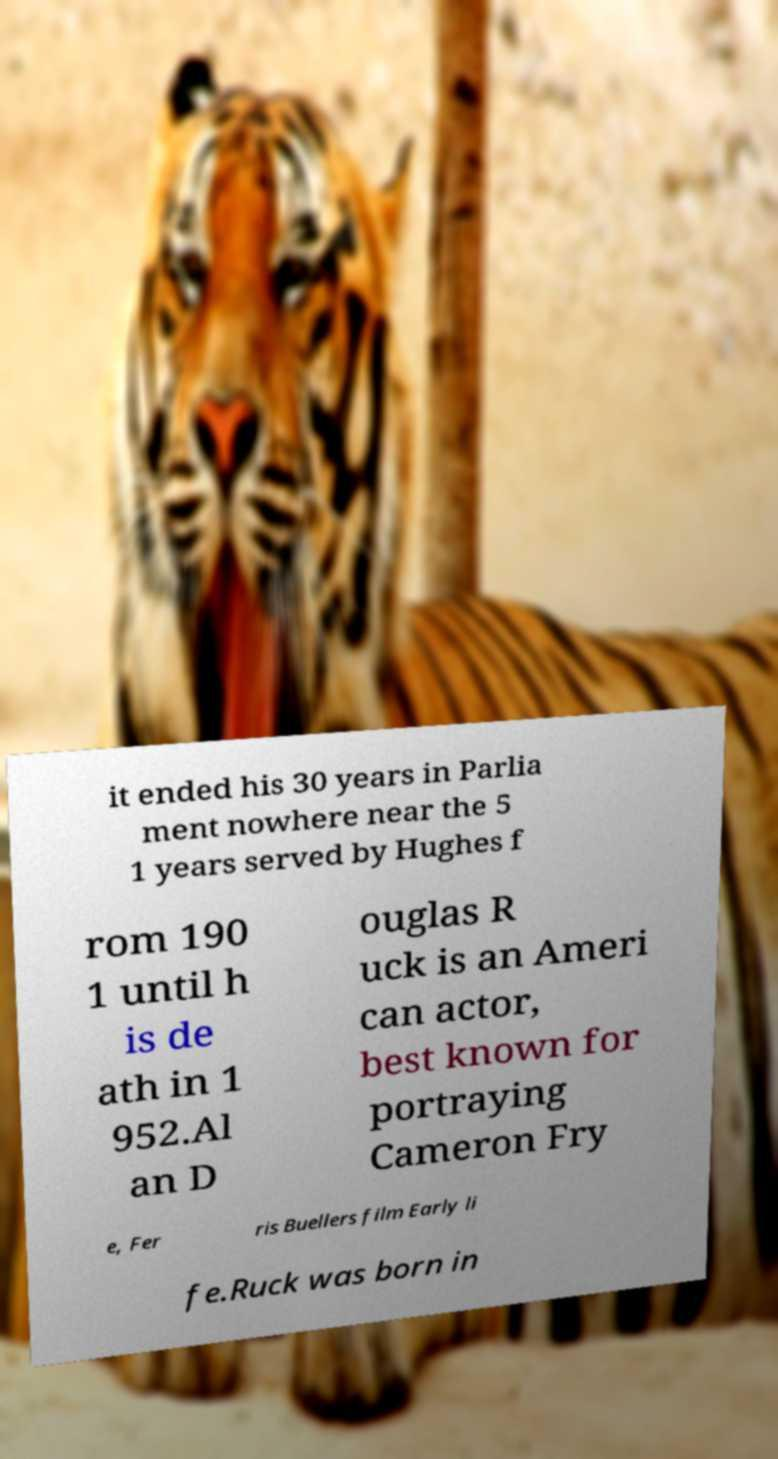Can you accurately transcribe the text from the provided image for me? it ended his 30 years in Parlia ment nowhere near the 5 1 years served by Hughes f rom 190 1 until h is de ath in 1 952.Al an D ouglas R uck is an Ameri can actor, best known for portraying Cameron Fry e, Fer ris Buellers film Early li fe.Ruck was born in 